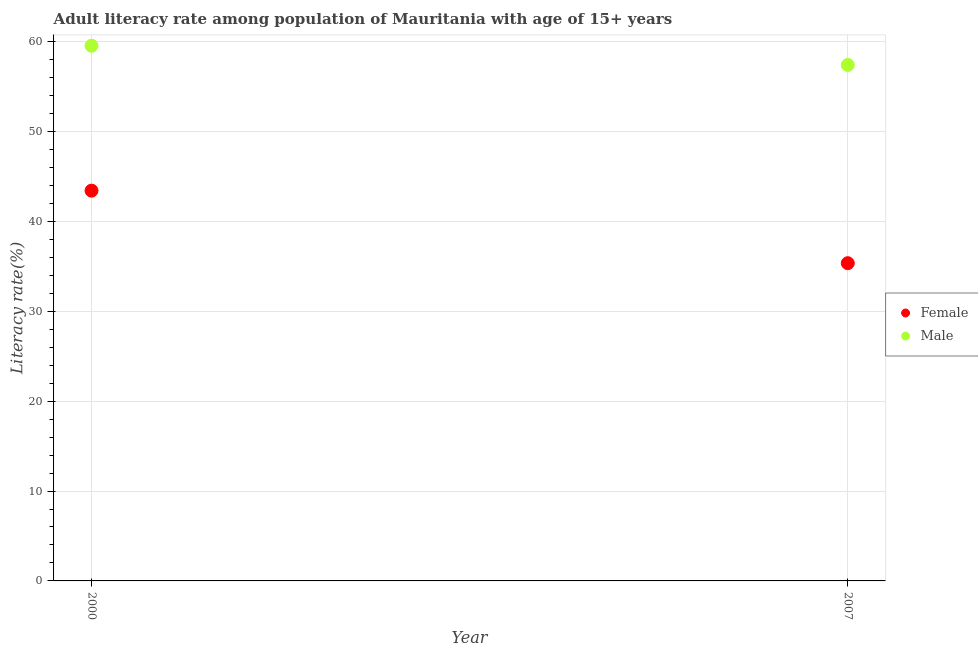How many different coloured dotlines are there?
Keep it short and to the point. 2. What is the female adult literacy rate in 2007?
Your answer should be very brief. 35.35. Across all years, what is the maximum female adult literacy rate?
Make the answer very short. 43.42. Across all years, what is the minimum female adult literacy rate?
Provide a short and direct response. 35.35. In which year was the female adult literacy rate maximum?
Provide a succinct answer. 2000. What is the total female adult literacy rate in the graph?
Provide a succinct answer. 78.77. What is the difference between the female adult literacy rate in 2000 and that in 2007?
Give a very brief answer. 8.07. What is the difference between the male adult literacy rate in 2007 and the female adult literacy rate in 2000?
Offer a very short reply. 13.99. What is the average female adult literacy rate per year?
Ensure brevity in your answer.  39.38. In the year 2000, what is the difference between the male adult literacy rate and female adult literacy rate?
Your response must be concise. 16.12. In how many years, is the male adult literacy rate greater than 8 %?
Provide a succinct answer. 2. What is the ratio of the male adult literacy rate in 2000 to that in 2007?
Offer a very short reply. 1.04. In how many years, is the female adult literacy rate greater than the average female adult literacy rate taken over all years?
Make the answer very short. 1. Is the male adult literacy rate strictly greater than the female adult literacy rate over the years?
Ensure brevity in your answer.  Yes. Is the female adult literacy rate strictly less than the male adult literacy rate over the years?
Offer a terse response. Yes. How many dotlines are there?
Your response must be concise. 2. What is the difference between two consecutive major ticks on the Y-axis?
Keep it short and to the point. 10. Does the graph contain any zero values?
Your response must be concise. No. Where does the legend appear in the graph?
Give a very brief answer. Center right. How many legend labels are there?
Provide a short and direct response. 2. What is the title of the graph?
Offer a terse response. Adult literacy rate among population of Mauritania with age of 15+ years. What is the label or title of the Y-axis?
Ensure brevity in your answer.  Literacy rate(%). What is the Literacy rate(%) in Female in 2000?
Keep it short and to the point. 43.42. What is the Literacy rate(%) in Male in 2000?
Make the answer very short. 59.54. What is the Literacy rate(%) of Female in 2007?
Offer a terse response. 35.35. What is the Literacy rate(%) in Male in 2007?
Ensure brevity in your answer.  57.4. Across all years, what is the maximum Literacy rate(%) in Female?
Your answer should be compact. 43.42. Across all years, what is the maximum Literacy rate(%) in Male?
Your response must be concise. 59.54. Across all years, what is the minimum Literacy rate(%) of Female?
Keep it short and to the point. 35.35. Across all years, what is the minimum Literacy rate(%) of Male?
Ensure brevity in your answer.  57.4. What is the total Literacy rate(%) of Female in the graph?
Provide a short and direct response. 78.77. What is the total Literacy rate(%) of Male in the graph?
Your response must be concise. 116.94. What is the difference between the Literacy rate(%) in Female in 2000 and that in 2007?
Keep it short and to the point. 8.07. What is the difference between the Literacy rate(%) of Male in 2000 and that in 2007?
Offer a very short reply. 2.14. What is the difference between the Literacy rate(%) in Female in 2000 and the Literacy rate(%) in Male in 2007?
Your answer should be very brief. -13.99. What is the average Literacy rate(%) in Female per year?
Your answer should be very brief. 39.38. What is the average Literacy rate(%) in Male per year?
Keep it short and to the point. 58.47. In the year 2000, what is the difference between the Literacy rate(%) in Female and Literacy rate(%) in Male?
Give a very brief answer. -16.12. In the year 2007, what is the difference between the Literacy rate(%) in Female and Literacy rate(%) in Male?
Give a very brief answer. -22.06. What is the ratio of the Literacy rate(%) of Female in 2000 to that in 2007?
Your response must be concise. 1.23. What is the ratio of the Literacy rate(%) of Male in 2000 to that in 2007?
Provide a short and direct response. 1.04. What is the difference between the highest and the second highest Literacy rate(%) of Female?
Your answer should be compact. 8.07. What is the difference between the highest and the second highest Literacy rate(%) in Male?
Make the answer very short. 2.14. What is the difference between the highest and the lowest Literacy rate(%) of Female?
Your response must be concise. 8.07. What is the difference between the highest and the lowest Literacy rate(%) in Male?
Offer a very short reply. 2.14. 